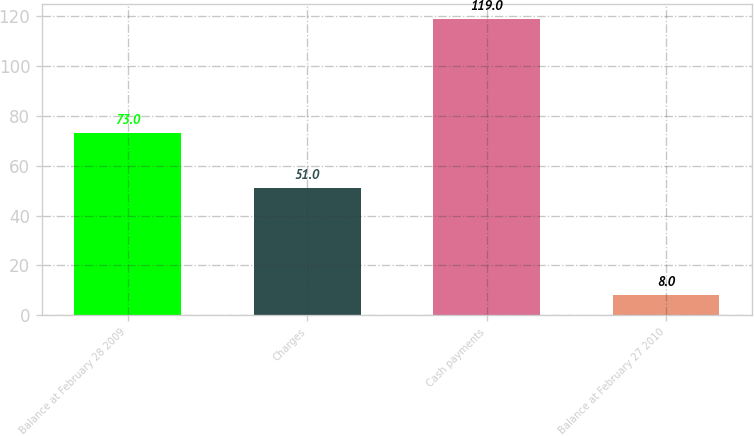Convert chart to OTSL. <chart><loc_0><loc_0><loc_500><loc_500><bar_chart><fcel>Balance at February 28 2009<fcel>Charges<fcel>Cash payments<fcel>Balance at February 27 2010<nl><fcel>73<fcel>51<fcel>119<fcel>8<nl></chart> 